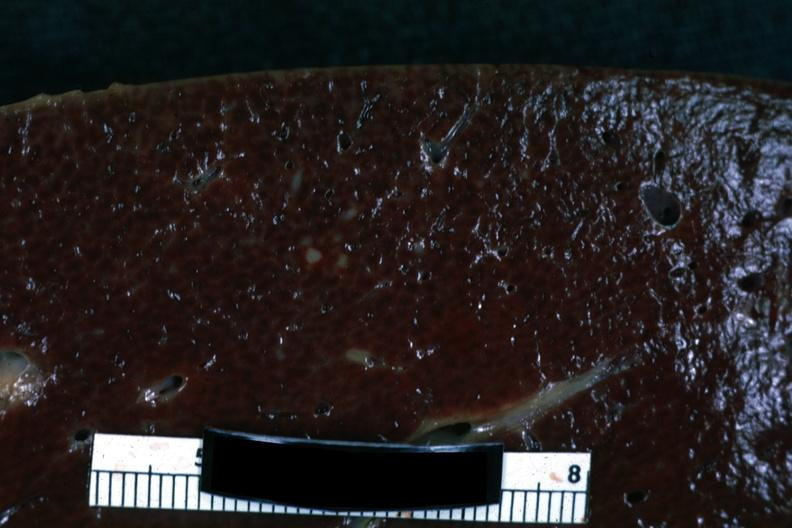s granulosa cell tumor present?
Answer the question using a single word or phrase. No 